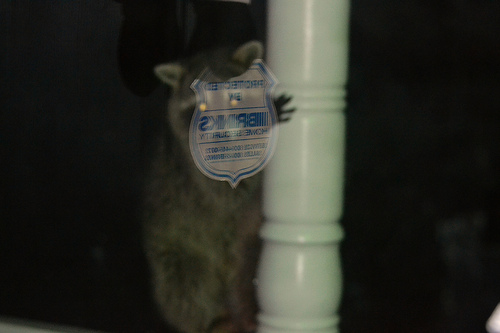<image>
Is the raccoon in front of the pole? No. The raccoon is not in front of the pole. The spatial positioning shows a different relationship between these objects. 